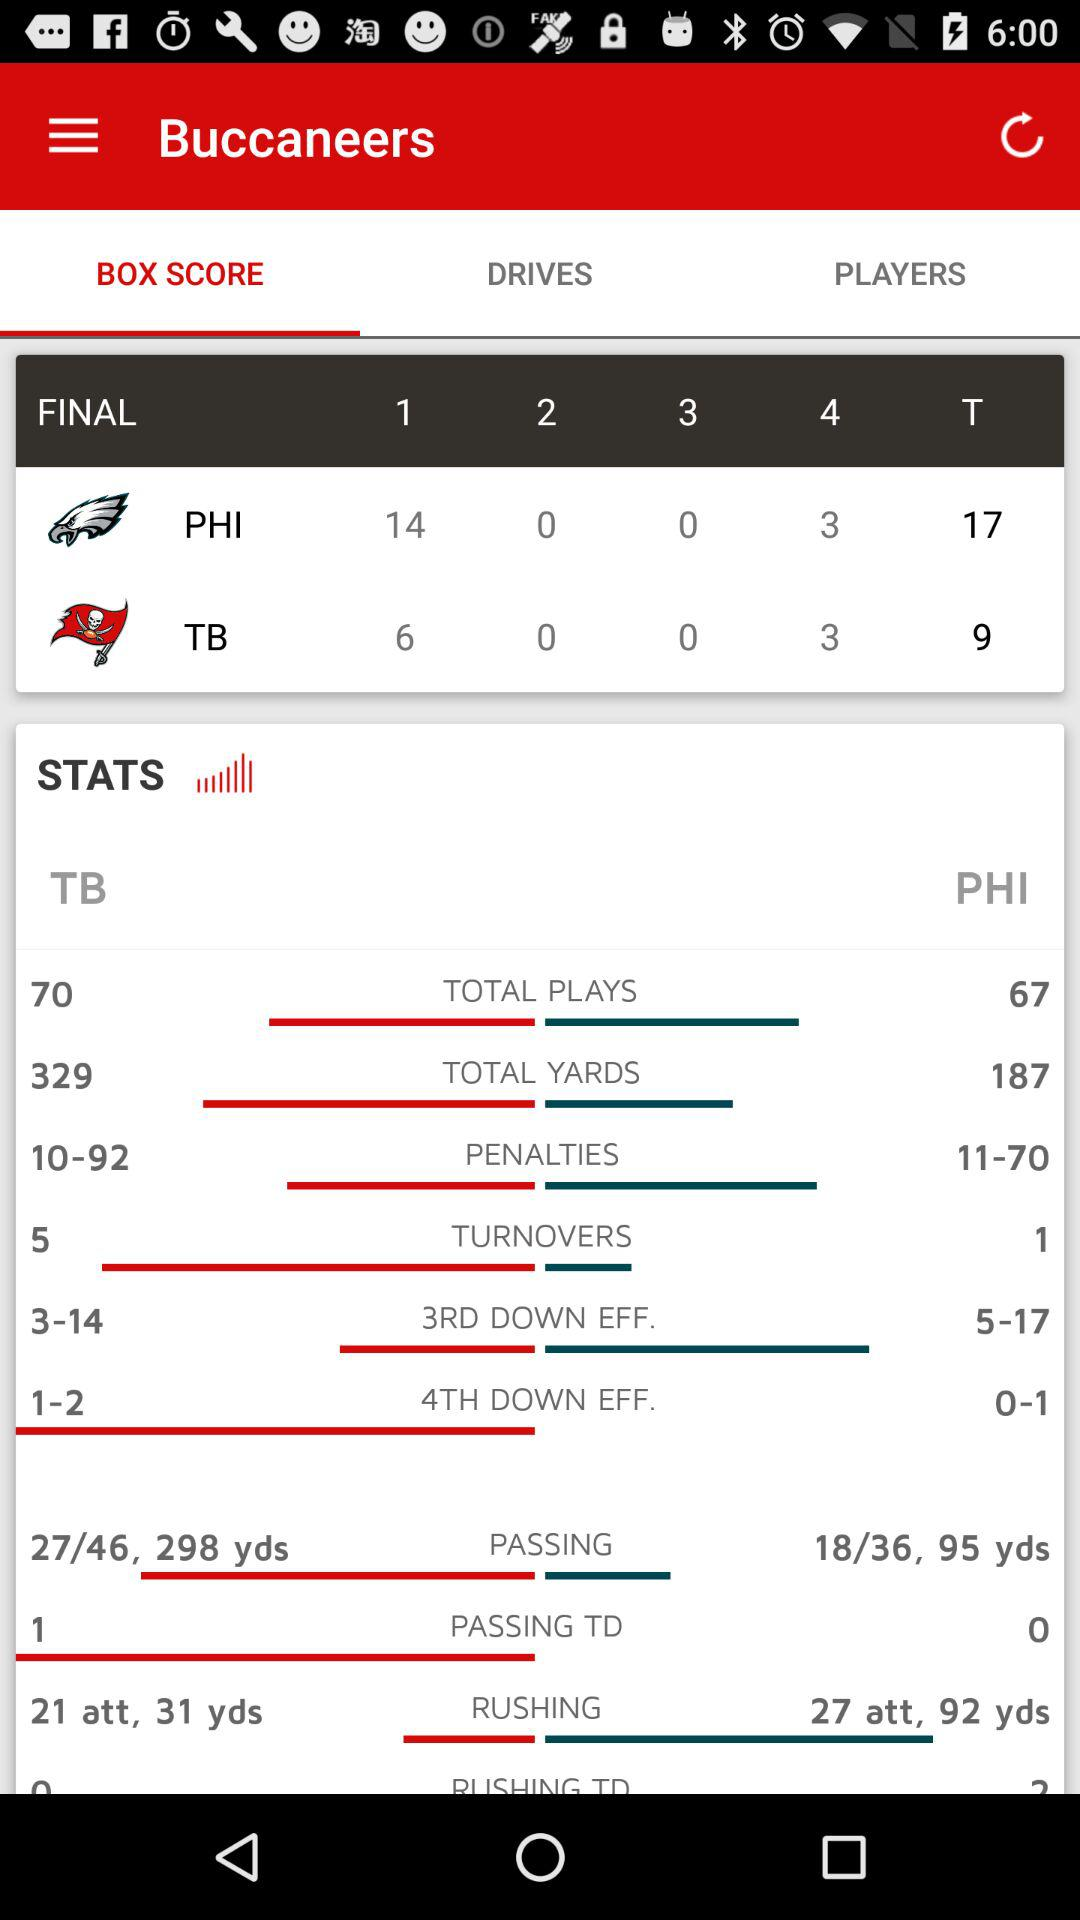How many more rushing yards did the Buccaneers have than the Eagles?
Answer the question using a single word or phrase. 61 